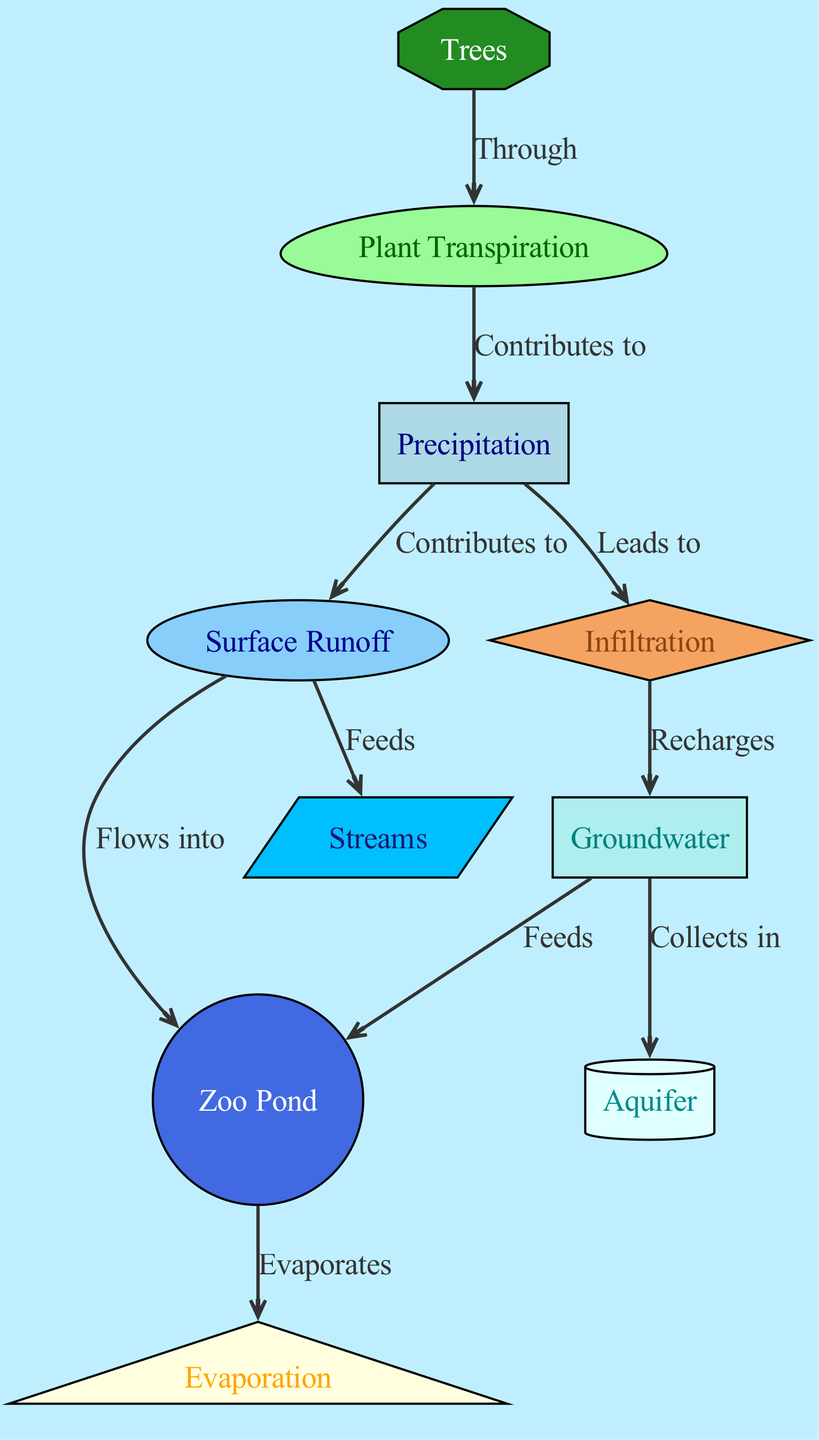What are the two primary sources of water input in the diagram? The diagram shows "Precipitation" and "Surface Runoff" as the two primary inputs. "Precipitation" falls from the atmosphere, while "Surface Runoff" is water that flows across the surface after precipitation.
Answer: Precipitation, Surface Runoff How many edges are present in the diagram? By counting the connections (edges) between the nodes, there are a total of 10 edges shown in the diagram.
Answer: 10 Which node collects the "Groundwater"? The "Aquifer" node is labeled as the place where "Groundwater" collects, as indicated by the directed edge from "Groundwater" to "Aquifer".
Answer: Aquifer What is the direct output of "Pond" in the cycle? The diagram indicates that the "Pond" directly leads to "Evaporation" as it shows an edge flowing from "Pond" to "Evaporation".
Answer: Evaporation What role do trees play in this water cycle? "Trees" contribute to "Plant Transpiration" as depicted by the edge from "Trees" to "Transpiration", indicating the water release process from trees into the atmosphere.
Answer: Plant Transpiration What happens to the surface runoff in the context of this diagram? "Surface Runoff" flows into both "Zoo Pond" and "Streams", as indicated by the edges flowing from "Surface Runoff" to these two nodes. Hence, it plays an essential role in water distribution within the habitat.
Answer: Flows into Pond and Streams How does "Transpiration" contribute to the overall water cycle? "Transpiration" contributes to "Precipitation", creating a loop in the cycle where water vapor released by plants eventually falls back to the ground as precipitation. This connection is shown by the edge from "Transpiration" to "Precipitation".
Answer: Contributes to Precipitation What is the ultimate sink for water after it goes through "Infiltration"? The "Groundwater" serves as the ultimate sink, where water infiltrated into the ground is stored, as indicated by the edge leading from "Infiltration" to "Groundwater".
Answer: Groundwater 